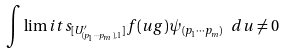Convert formula to latex. <formula><loc_0><loc_0><loc_500><loc_500>\int \lim i t s _ { [ U ^ { \prime } _ { ( p _ { 1 } \cdots p _ { m } ) , 1 } ] } f ( u g ) \psi _ { ( p _ { 1 } \cdots p _ { m } ) } \ d u \neq 0</formula> 